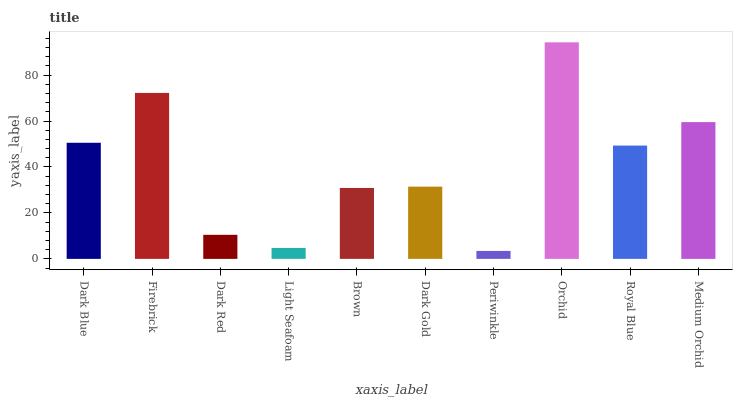Is Periwinkle the minimum?
Answer yes or no. Yes. Is Orchid the maximum?
Answer yes or no. Yes. Is Firebrick the minimum?
Answer yes or no. No. Is Firebrick the maximum?
Answer yes or no. No. Is Firebrick greater than Dark Blue?
Answer yes or no. Yes. Is Dark Blue less than Firebrick?
Answer yes or no. Yes. Is Dark Blue greater than Firebrick?
Answer yes or no. No. Is Firebrick less than Dark Blue?
Answer yes or no. No. Is Royal Blue the high median?
Answer yes or no. Yes. Is Dark Gold the low median?
Answer yes or no. Yes. Is Medium Orchid the high median?
Answer yes or no. No. Is Medium Orchid the low median?
Answer yes or no. No. 